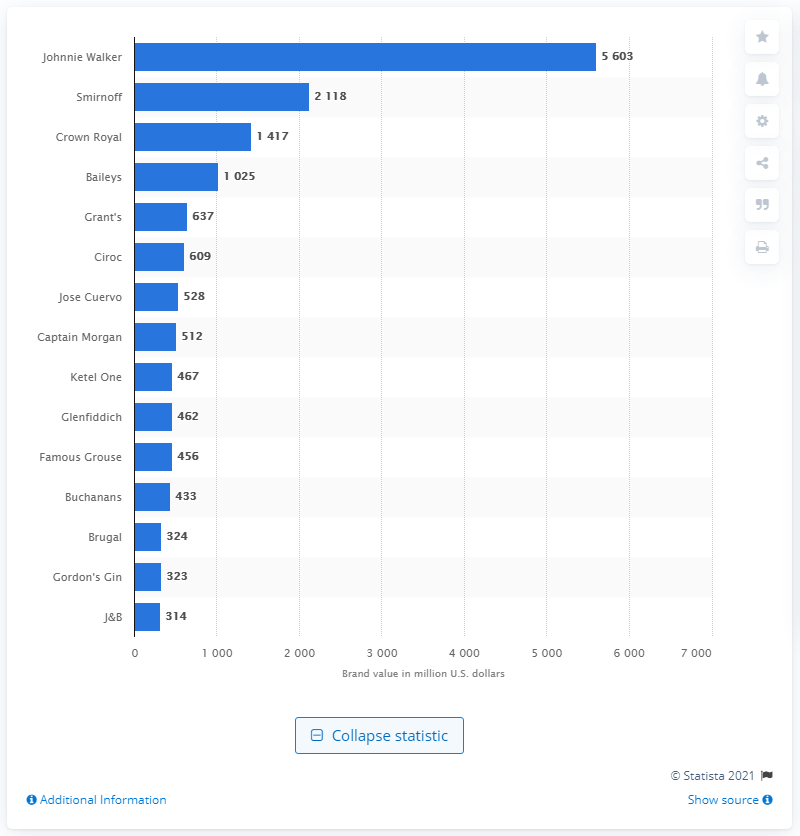Highlight a few significant elements in this photo. As of December 31, 2014, the value of the Johnnie Walker brand was approximately 5,603. 